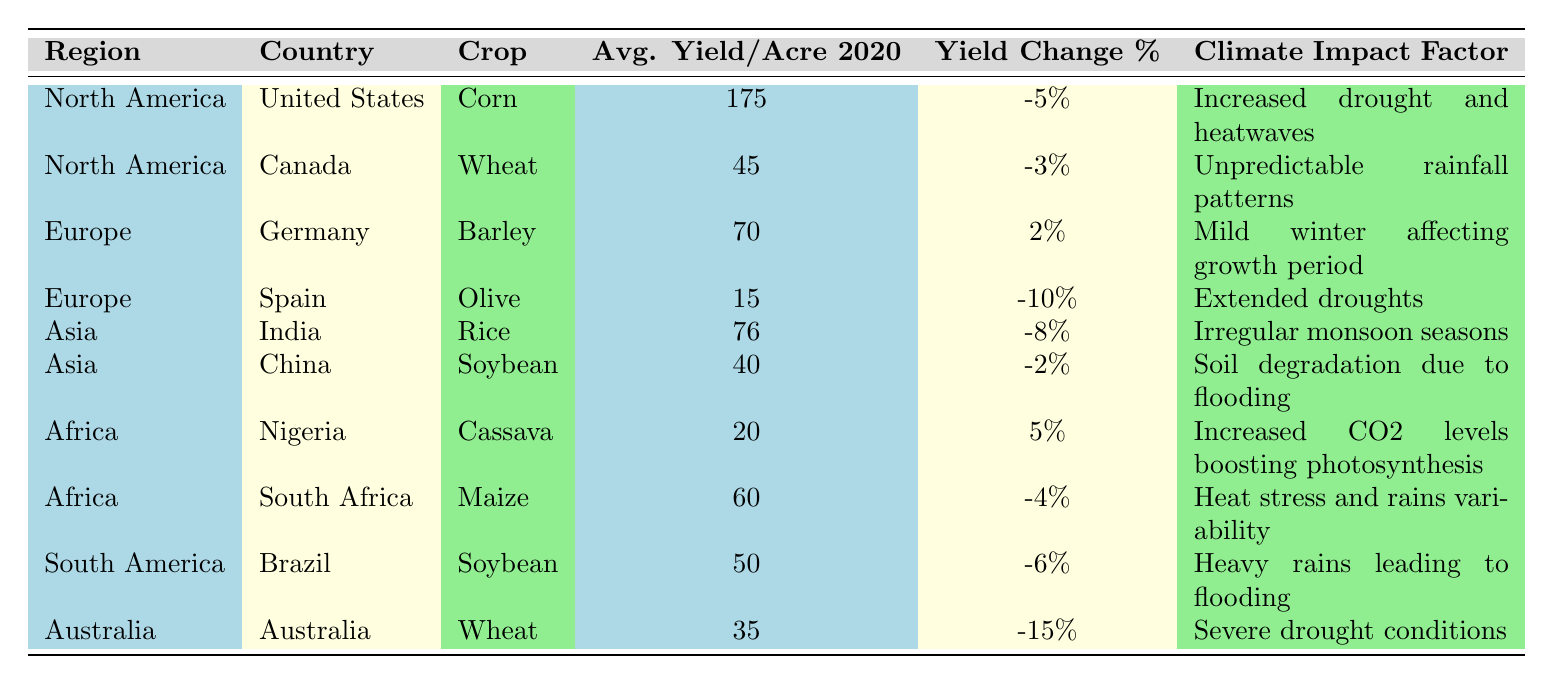What is the average yield per acre for corn in the United States in 2020? The table lists corn's average yield per acre in the United States as 175.
Answer: 175 Which crop experienced the highest yield change percentage in 2020? Reviewing the table, the highest yield change percentage is for Australia’s wheat, with a change of -15%.
Answer: -15% In which region did Nigeria and South Africa report their agricultural yields? Both Nigeria and South Africa are listed under the Africa region in the table.
Answer: Africa What was the yield change percentage for wheat in Canada? According to the table, Canada’s wheat had a yield change percentage of -3%.
Answer: -3% Is it true that the average yield per acre for olive in Spain was lower than for rice in India? The average yield for olive in Spain is 15, while rice in India has an average yield of 76, thus the statement is true.
Answer: True Which climate impact factor is associated with China’s soybean yield? The table specifies that the climate impact factor for China’s soybean is "Soil degradation due to flooding."
Answer: Soil degradation due to flooding How much greater was the average yield of corn in the United States compared to wheat in Australia? The average yield for corn is 175, while for wheat in Australia, it is 35. The difference is 175 - 35 = 140.
Answer: 140 How many regions reported a negative yield change percentage? From the table, the following regions reported negative yield change percentages: North America (United States & Canada), Europe (Spain), Asia (India & China), South Africa (Africa), and Brazil (South America), totaling 6 regions.
Answer: 6 Considering only countries from North America, what is the average yield change percentage? The yields listed for North America are -5% (U.S.) and -3% (Canada). The average is (-5 + (-3))/2 = -4%.
Answer: -4% Which country had the lowest average yield per acre in 2020? The table shows that Spain’s olive had the lowest yield per acre at 15.
Answer: 15 